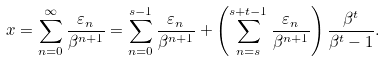Convert formula to latex. <formula><loc_0><loc_0><loc_500><loc_500>x = \sum _ { n = 0 } ^ { \infty } \frac { \varepsilon _ { n } } { \beta ^ { n + 1 } } = \sum _ { n = 0 } ^ { s - 1 } \frac { \varepsilon _ { n } } { \beta ^ { n + 1 } } + \left ( \sum _ { n = s } ^ { s + t - 1 } \frac { \varepsilon _ { n } } { \beta ^ { n + 1 } } \right ) \frac { \beta ^ { t } } { \beta ^ { t } - 1 } .</formula> 